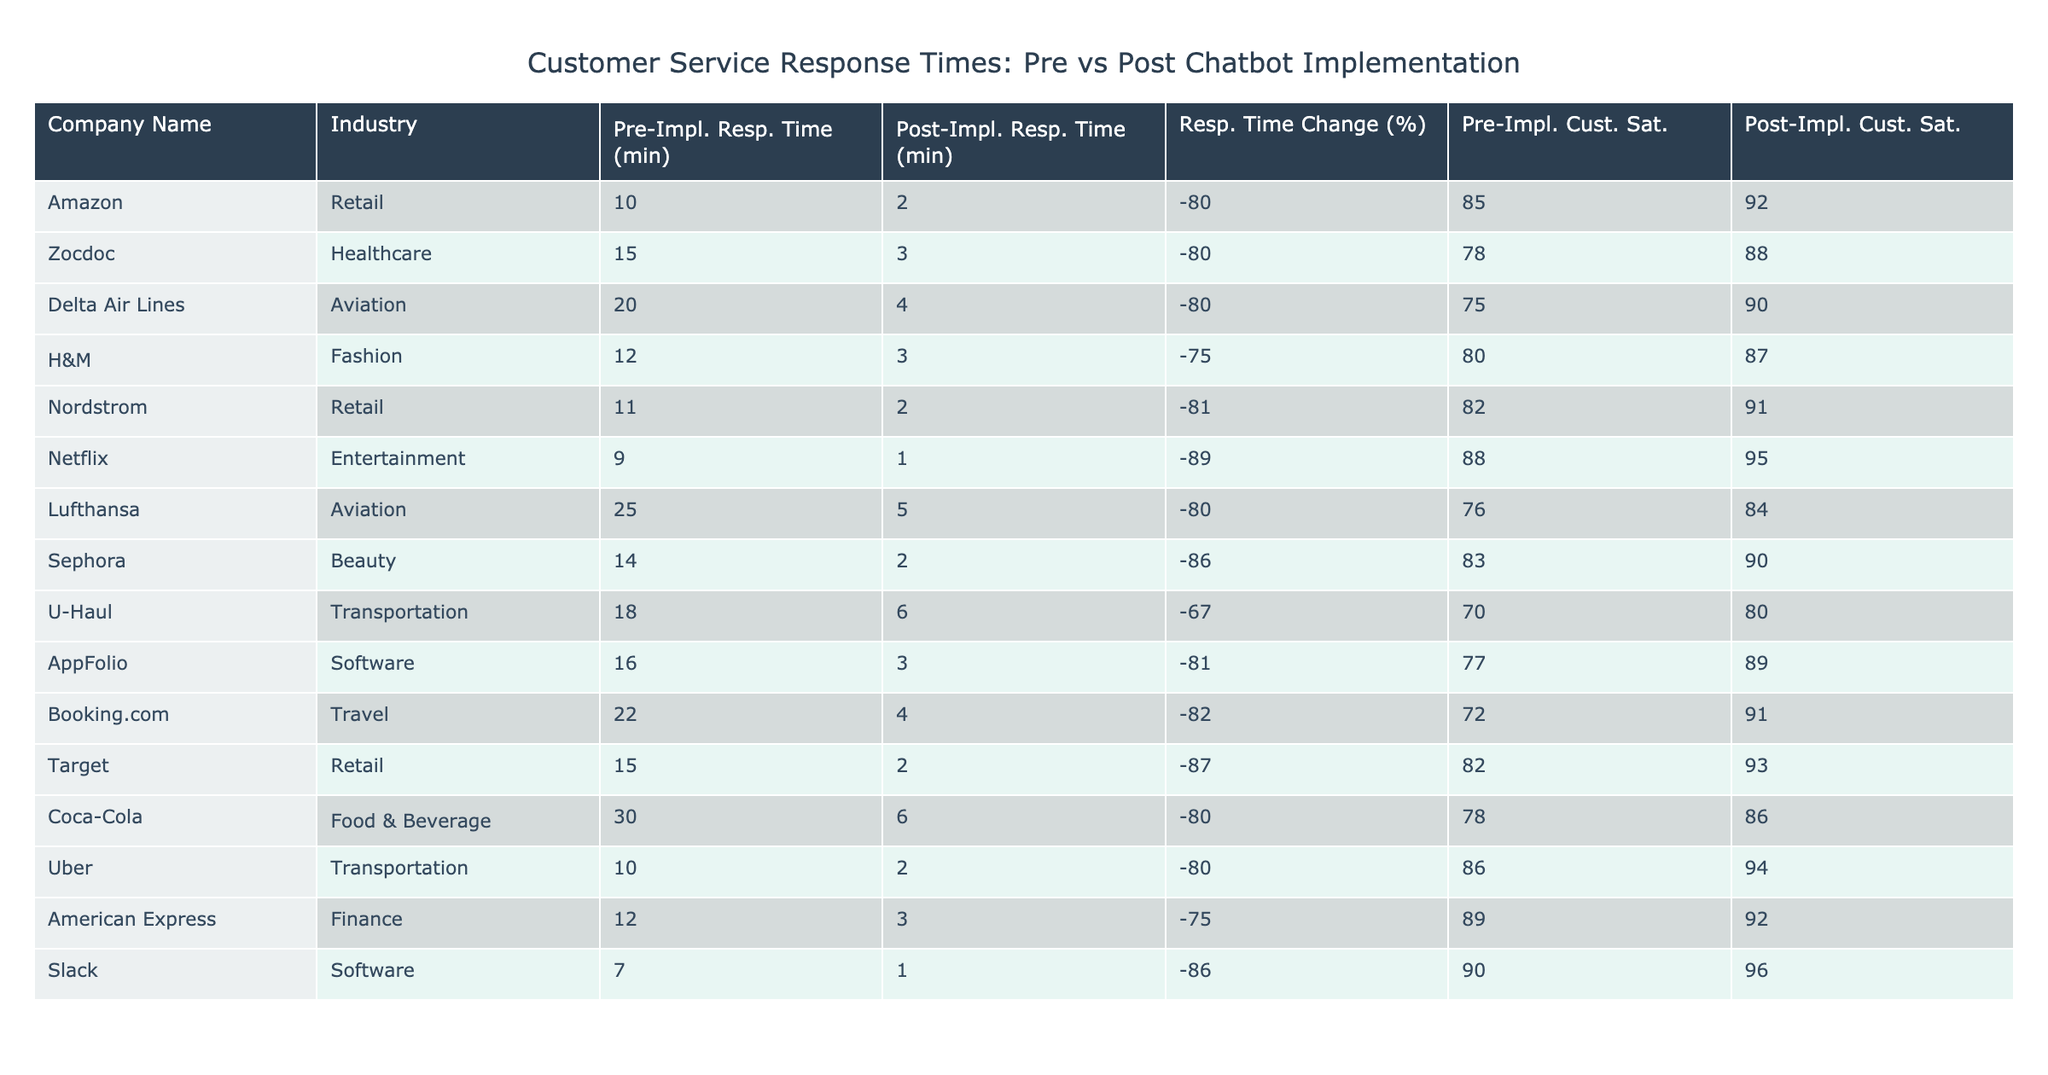What is the average pre-implementation response time across all companies? To find the average pre-implementation response time, add all the pre-implementation times: 10 + 15 + 20 + 12 + 11 + 9 + 25 + 14 + 18 + 16 + 22 + 15 + 30 + 10 + 12 + 7 =  297, and then divide by the number of companies, which is 16. So, 297 / 16 = 18.5625.
Answer: 18.56 Which company had the greatest reduction in response time after chatbot implementation? From the percentage change column, the greatest reductions are listed; several companies show an 89% reduction in response time, which includes Netflix.
Answer: Netflix Did any company see an increase in customer satisfaction after implementing chatbots? By comparing the customer satisfaction scores pre- and post-implementation, we see that every company listed has an increase in customer satisfaction scores.
Answer: Yes What is the relationship between the percentage change in response time and customer satisfaction post-implementation? To analyze this, we can observe that generally, companies with higher percentage reductions in response times also report higher customer satisfaction scores post-implementation. For example, Target, with an 87% reduction, has a post-satisfaction score of 93, which aligns with this trend.
Answer: Generally positive How many companies achieved a post-implementation average response time of under 5 minutes? By checking the post-implementation response times: Amazon (2), Zocdoc (3), Delta Air Lines (4), H&M (3), Nordstrom (2), Netflix (1), Sephora (2), and Target (2), we find that 8 companies have response times under 5 minutes.
Answer: 8 Which industry had the highest post-implementation average response time? Examining the post-implementation times, the Aviation industry, represented by Lufthansa at 5 minutes and Delta Air Lines at 4 minutes, has the highest scores compared to other industries in the table.
Answer: Aviation What is the average customer satisfaction score for the healthcare industry post-implementation? We look for companies within the healthcare industry in the table, specifically Zocdoc, which had a customer satisfaction score of 88 post-implementation. Since there's only one company, the average is also 88.
Answer: 88 Which company improved their customer satisfaction score by the least amount after implementing chatbots? Looking at the customer satisfaction score changes: U-Haul increased from 70 to 80, which is a 10-point increase—lower than all others in the table.
Answer: U-Haul Which company experienced the largest post-implementation average response time, but still had a significant percentage change in response time? Looking at the post-implementation times, the company with the largest time is Lufthansa (5 minutes), which also had a significant percentage change of -80%.
Answer: Lufthansa 